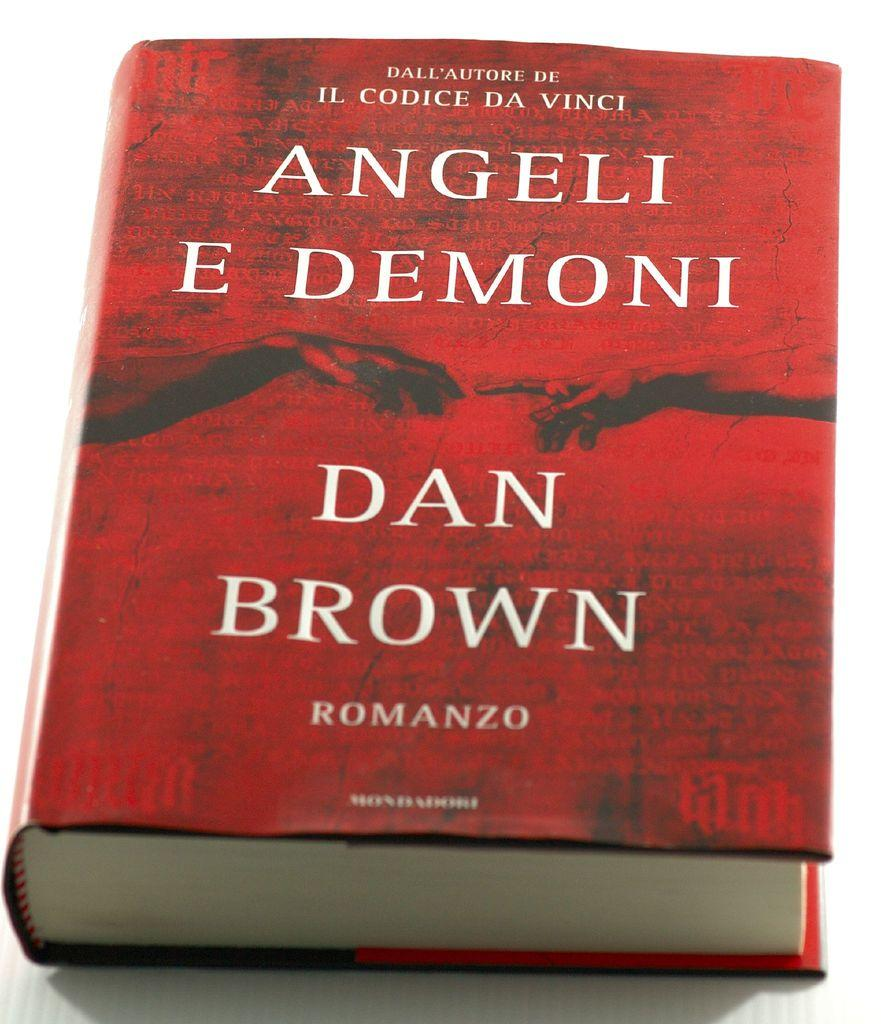<image>
Relay a brief, clear account of the picture shown. The front cover of Angeli E Demoni by Dan Brown. 